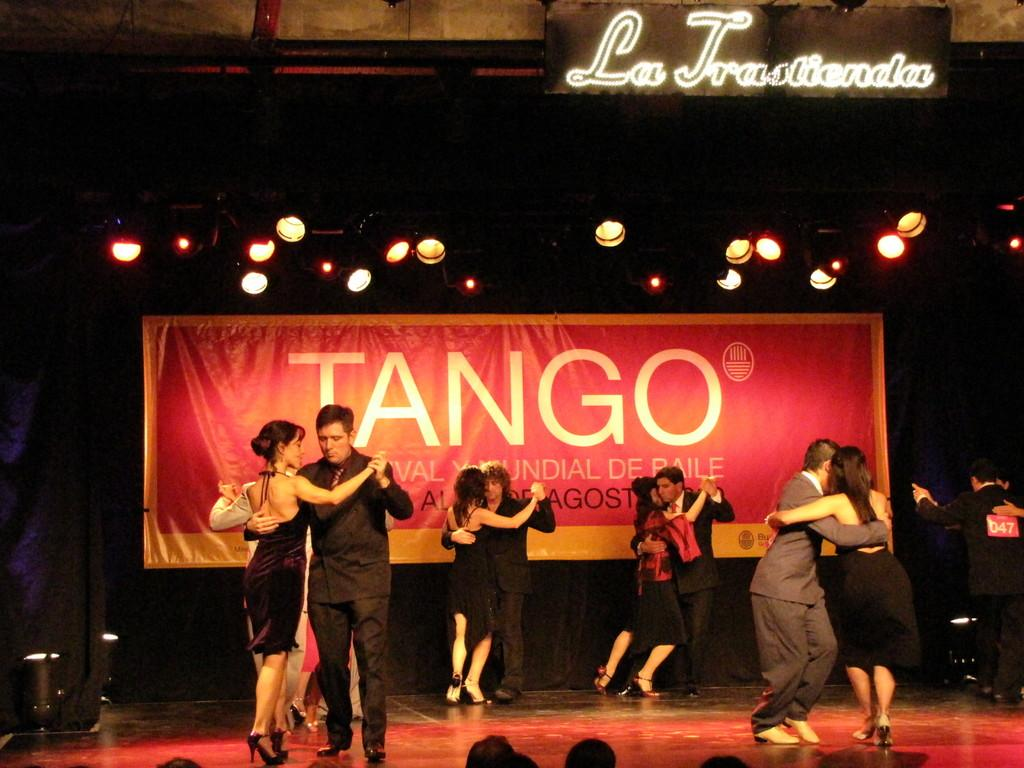What is happening on stage in the image? There are six couples dancing on stage. What can be seen in the background of the image? There is a banner and lights visible in the background. How many roses are being held by the rabbit in the image? There is no rabbit or rose present in the image. What type of muscle is being exercised by the dancers in the image? The image does not provide information about the specific muscles being used by the dancers. 